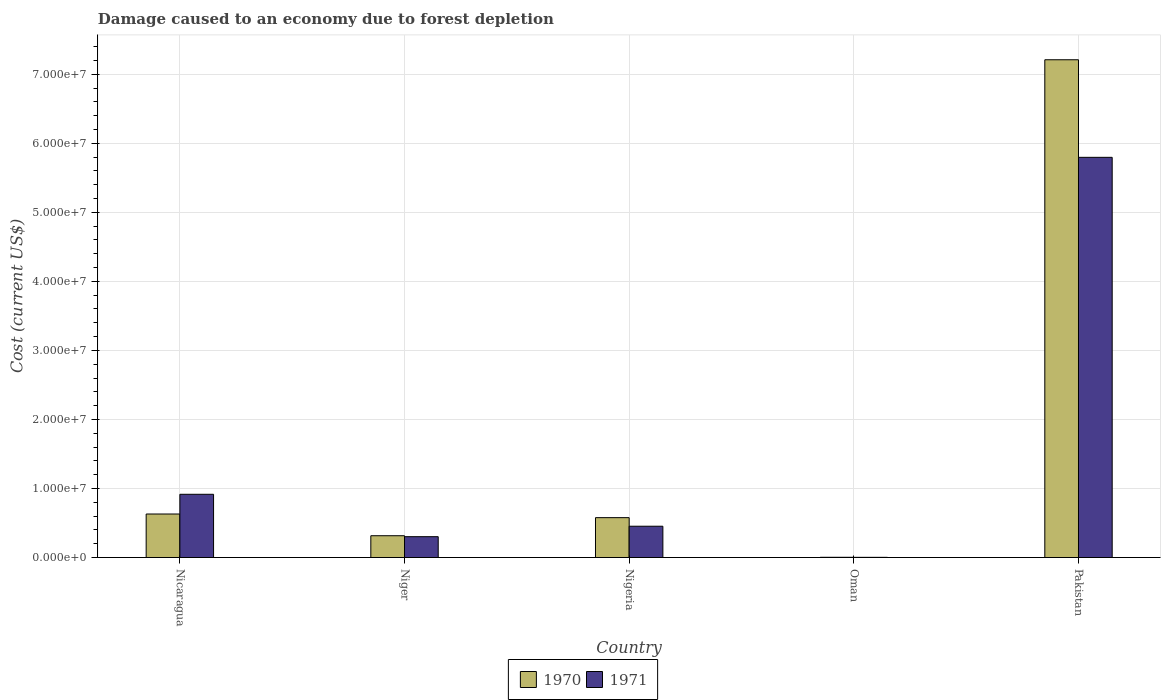Are the number of bars on each tick of the X-axis equal?
Offer a terse response. Yes. What is the label of the 3rd group of bars from the left?
Make the answer very short. Nigeria. In how many cases, is the number of bars for a given country not equal to the number of legend labels?
Your response must be concise. 0. What is the cost of damage caused due to forest depletion in 1971 in Niger?
Make the answer very short. 3.02e+06. Across all countries, what is the maximum cost of damage caused due to forest depletion in 1971?
Make the answer very short. 5.80e+07. Across all countries, what is the minimum cost of damage caused due to forest depletion in 1970?
Your answer should be compact. 3.33e+04. In which country was the cost of damage caused due to forest depletion in 1971 minimum?
Your answer should be very brief. Oman. What is the total cost of damage caused due to forest depletion in 1970 in the graph?
Give a very brief answer. 8.74e+07. What is the difference between the cost of damage caused due to forest depletion in 1970 in Nicaragua and that in Oman?
Keep it short and to the point. 6.27e+06. What is the difference between the cost of damage caused due to forest depletion in 1971 in Oman and the cost of damage caused due to forest depletion in 1970 in Niger?
Provide a short and direct response. -3.13e+06. What is the average cost of damage caused due to forest depletion in 1970 per country?
Your answer should be compact. 1.75e+07. What is the difference between the cost of damage caused due to forest depletion of/in 1970 and cost of damage caused due to forest depletion of/in 1971 in Nigeria?
Offer a terse response. 1.24e+06. In how many countries, is the cost of damage caused due to forest depletion in 1971 greater than 38000000 US$?
Your response must be concise. 1. What is the ratio of the cost of damage caused due to forest depletion in 1970 in Niger to that in Nigeria?
Provide a short and direct response. 0.55. Is the cost of damage caused due to forest depletion in 1970 in Niger less than that in Pakistan?
Ensure brevity in your answer.  Yes. What is the difference between the highest and the second highest cost of damage caused due to forest depletion in 1970?
Ensure brevity in your answer.  6.63e+07. What is the difference between the highest and the lowest cost of damage caused due to forest depletion in 1971?
Provide a short and direct response. 5.79e+07. In how many countries, is the cost of damage caused due to forest depletion in 1971 greater than the average cost of damage caused due to forest depletion in 1971 taken over all countries?
Offer a terse response. 1. What does the 1st bar from the left in Pakistan represents?
Offer a very short reply. 1970. What does the 2nd bar from the right in Nicaragua represents?
Your response must be concise. 1970. Are all the bars in the graph horizontal?
Provide a succinct answer. No. What is the difference between two consecutive major ticks on the Y-axis?
Offer a very short reply. 1.00e+07. Are the values on the major ticks of Y-axis written in scientific E-notation?
Your answer should be very brief. Yes. Does the graph contain any zero values?
Your response must be concise. No. What is the title of the graph?
Offer a terse response. Damage caused to an economy due to forest depletion. Does "2014" appear as one of the legend labels in the graph?
Give a very brief answer. No. What is the label or title of the Y-axis?
Keep it short and to the point. Cost (current US$). What is the Cost (current US$) in 1970 in Nicaragua?
Ensure brevity in your answer.  6.30e+06. What is the Cost (current US$) of 1971 in Nicaragua?
Provide a succinct answer. 9.16e+06. What is the Cost (current US$) of 1970 in Niger?
Your response must be concise. 3.16e+06. What is the Cost (current US$) of 1971 in Niger?
Give a very brief answer. 3.02e+06. What is the Cost (current US$) of 1970 in Nigeria?
Keep it short and to the point. 5.77e+06. What is the Cost (current US$) of 1971 in Nigeria?
Your answer should be very brief. 4.53e+06. What is the Cost (current US$) of 1970 in Oman?
Provide a succinct answer. 3.33e+04. What is the Cost (current US$) of 1971 in Oman?
Provide a short and direct response. 2.65e+04. What is the Cost (current US$) in 1970 in Pakistan?
Ensure brevity in your answer.  7.21e+07. What is the Cost (current US$) of 1971 in Pakistan?
Offer a very short reply. 5.80e+07. Across all countries, what is the maximum Cost (current US$) of 1970?
Make the answer very short. 7.21e+07. Across all countries, what is the maximum Cost (current US$) in 1971?
Ensure brevity in your answer.  5.80e+07. Across all countries, what is the minimum Cost (current US$) of 1970?
Keep it short and to the point. 3.33e+04. Across all countries, what is the minimum Cost (current US$) in 1971?
Provide a short and direct response. 2.65e+04. What is the total Cost (current US$) in 1970 in the graph?
Provide a succinct answer. 8.74e+07. What is the total Cost (current US$) in 1971 in the graph?
Provide a succinct answer. 7.47e+07. What is the difference between the Cost (current US$) in 1970 in Nicaragua and that in Niger?
Provide a succinct answer. 3.15e+06. What is the difference between the Cost (current US$) of 1971 in Nicaragua and that in Niger?
Ensure brevity in your answer.  6.14e+06. What is the difference between the Cost (current US$) of 1970 in Nicaragua and that in Nigeria?
Ensure brevity in your answer.  5.29e+05. What is the difference between the Cost (current US$) of 1971 in Nicaragua and that in Nigeria?
Give a very brief answer. 4.63e+06. What is the difference between the Cost (current US$) in 1970 in Nicaragua and that in Oman?
Offer a very short reply. 6.27e+06. What is the difference between the Cost (current US$) of 1971 in Nicaragua and that in Oman?
Offer a terse response. 9.13e+06. What is the difference between the Cost (current US$) in 1970 in Nicaragua and that in Pakistan?
Your answer should be compact. -6.58e+07. What is the difference between the Cost (current US$) in 1971 in Nicaragua and that in Pakistan?
Your answer should be very brief. -4.88e+07. What is the difference between the Cost (current US$) in 1970 in Niger and that in Nigeria?
Make the answer very short. -2.62e+06. What is the difference between the Cost (current US$) in 1971 in Niger and that in Nigeria?
Provide a succinct answer. -1.51e+06. What is the difference between the Cost (current US$) in 1970 in Niger and that in Oman?
Ensure brevity in your answer.  3.12e+06. What is the difference between the Cost (current US$) in 1971 in Niger and that in Oman?
Offer a very short reply. 2.99e+06. What is the difference between the Cost (current US$) in 1970 in Niger and that in Pakistan?
Your answer should be compact. -6.89e+07. What is the difference between the Cost (current US$) in 1971 in Niger and that in Pakistan?
Your response must be concise. -5.49e+07. What is the difference between the Cost (current US$) of 1970 in Nigeria and that in Oman?
Your answer should be very brief. 5.74e+06. What is the difference between the Cost (current US$) in 1971 in Nigeria and that in Oman?
Offer a very short reply. 4.51e+06. What is the difference between the Cost (current US$) in 1970 in Nigeria and that in Pakistan?
Your answer should be very brief. -6.63e+07. What is the difference between the Cost (current US$) in 1971 in Nigeria and that in Pakistan?
Give a very brief answer. -5.34e+07. What is the difference between the Cost (current US$) in 1970 in Oman and that in Pakistan?
Ensure brevity in your answer.  -7.21e+07. What is the difference between the Cost (current US$) of 1971 in Oman and that in Pakistan?
Ensure brevity in your answer.  -5.79e+07. What is the difference between the Cost (current US$) of 1970 in Nicaragua and the Cost (current US$) of 1971 in Niger?
Offer a terse response. 3.28e+06. What is the difference between the Cost (current US$) in 1970 in Nicaragua and the Cost (current US$) in 1971 in Nigeria?
Provide a short and direct response. 1.77e+06. What is the difference between the Cost (current US$) of 1970 in Nicaragua and the Cost (current US$) of 1971 in Oman?
Ensure brevity in your answer.  6.28e+06. What is the difference between the Cost (current US$) in 1970 in Nicaragua and the Cost (current US$) in 1971 in Pakistan?
Your answer should be compact. -5.17e+07. What is the difference between the Cost (current US$) of 1970 in Niger and the Cost (current US$) of 1971 in Nigeria?
Make the answer very short. -1.38e+06. What is the difference between the Cost (current US$) in 1970 in Niger and the Cost (current US$) in 1971 in Oman?
Offer a terse response. 3.13e+06. What is the difference between the Cost (current US$) in 1970 in Niger and the Cost (current US$) in 1971 in Pakistan?
Make the answer very short. -5.48e+07. What is the difference between the Cost (current US$) of 1970 in Nigeria and the Cost (current US$) of 1971 in Oman?
Make the answer very short. 5.75e+06. What is the difference between the Cost (current US$) of 1970 in Nigeria and the Cost (current US$) of 1971 in Pakistan?
Keep it short and to the point. -5.22e+07. What is the difference between the Cost (current US$) of 1970 in Oman and the Cost (current US$) of 1971 in Pakistan?
Offer a terse response. -5.79e+07. What is the average Cost (current US$) of 1970 per country?
Provide a short and direct response. 1.75e+07. What is the average Cost (current US$) of 1971 per country?
Give a very brief answer. 1.49e+07. What is the difference between the Cost (current US$) in 1970 and Cost (current US$) in 1971 in Nicaragua?
Give a very brief answer. -2.86e+06. What is the difference between the Cost (current US$) in 1970 and Cost (current US$) in 1971 in Niger?
Your answer should be very brief. 1.37e+05. What is the difference between the Cost (current US$) of 1970 and Cost (current US$) of 1971 in Nigeria?
Keep it short and to the point. 1.24e+06. What is the difference between the Cost (current US$) of 1970 and Cost (current US$) of 1971 in Oman?
Offer a very short reply. 6781.75. What is the difference between the Cost (current US$) of 1970 and Cost (current US$) of 1971 in Pakistan?
Your answer should be compact. 1.41e+07. What is the ratio of the Cost (current US$) of 1970 in Nicaragua to that in Niger?
Your answer should be compact. 2. What is the ratio of the Cost (current US$) in 1971 in Nicaragua to that in Niger?
Give a very brief answer. 3.03. What is the ratio of the Cost (current US$) of 1970 in Nicaragua to that in Nigeria?
Your answer should be compact. 1.09. What is the ratio of the Cost (current US$) of 1971 in Nicaragua to that in Nigeria?
Ensure brevity in your answer.  2.02. What is the ratio of the Cost (current US$) of 1970 in Nicaragua to that in Oman?
Provide a short and direct response. 189.26. What is the ratio of the Cost (current US$) of 1971 in Nicaragua to that in Oman?
Offer a terse response. 345.28. What is the ratio of the Cost (current US$) of 1970 in Nicaragua to that in Pakistan?
Offer a very short reply. 0.09. What is the ratio of the Cost (current US$) in 1971 in Nicaragua to that in Pakistan?
Provide a short and direct response. 0.16. What is the ratio of the Cost (current US$) in 1970 in Niger to that in Nigeria?
Offer a terse response. 0.55. What is the ratio of the Cost (current US$) of 1971 in Niger to that in Nigeria?
Your answer should be compact. 0.67. What is the ratio of the Cost (current US$) in 1970 in Niger to that in Oman?
Offer a very short reply. 94.76. What is the ratio of the Cost (current US$) in 1971 in Niger to that in Oman?
Make the answer very short. 113.83. What is the ratio of the Cost (current US$) in 1970 in Niger to that in Pakistan?
Offer a terse response. 0.04. What is the ratio of the Cost (current US$) in 1971 in Niger to that in Pakistan?
Keep it short and to the point. 0.05. What is the ratio of the Cost (current US$) of 1970 in Nigeria to that in Oman?
Make the answer very short. 173.37. What is the ratio of the Cost (current US$) of 1971 in Nigeria to that in Oman?
Your response must be concise. 170.92. What is the ratio of the Cost (current US$) in 1970 in Nigeria to that in Pakistan?
Your response must be concise. 0.08. What is the ratio of the Cost (current US$) in 1971 in Nigeria to that in Pakistan?
Make the answer very short. 0.08. What is the ratio of the Cost (current US$) of 1970 in Oman to that in Pakistan?
Keep it short and to the point. 0. What is the difference between the highest and the second highest Cost (current US$) in 1970?
Offer a very short reply. 6.58e+07. What is the difference between the highest and the second highest Cost (current US$) of 1971?
Provide a succinct answer. 4.88e+07. What is the difference between the highest and the lowest Cost (current US$) in 1970?
Offer a very short reply. 7.21e+07. What is the difference between the highest and the lowest Cost (current US$) of 1971?
Your response must be concise. 5.79e+07. 